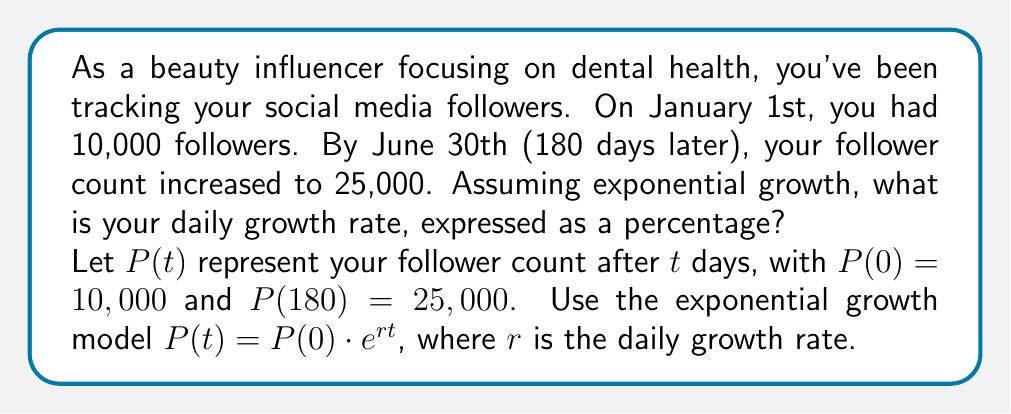Can you answer this question? To solve this problem, we'll use the exponential growth model and logarithms:

1) We start with the exponential growth equation:
   $P(t) = P(0) \cdot e^{rt}$

2) Plug in the known values:
   $25,000 = 10,000 \cdot e^{180r}$

3) Divide both sides by 10,000:
   $2.5 = e^{180r}$

4) Take the natural logarithm of both sides:
   $\ln(2.5) = \ln(e^{180r})$

5) Use the logarithm property $\ln(e^x) = x$:
   $\ln(2.5) = 180r$

6) Solve for $r$:
   $r = \frac{\ln(2.5)}{180}$

7) Calculate the value:
   $r = \frac{0.9162907318741551}{180} \approx 0.005090504066$

8) Convert to a percentage:
   $0.005090504066 \cdot 100\% \approx 0.5090504066\%$

Therefore, the daily growth rate is approximately 0.5091%.
Answer: The daily growth rate is approximately 0.5091%. 